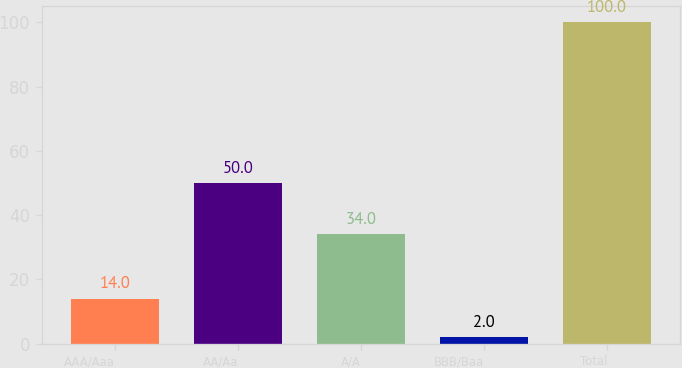Convert chart. <chart><loc_0><loc_0><loc_500><loc_500><bar_chart><fcel>AAA/Aaa<fcel>AA/Aa<fcel>A/A<fcel>BBB/Baa<fcel>Total<nl><fcel>14<fcel>50<fcel>34<fcel>2<fcel>100<nl></chart> 